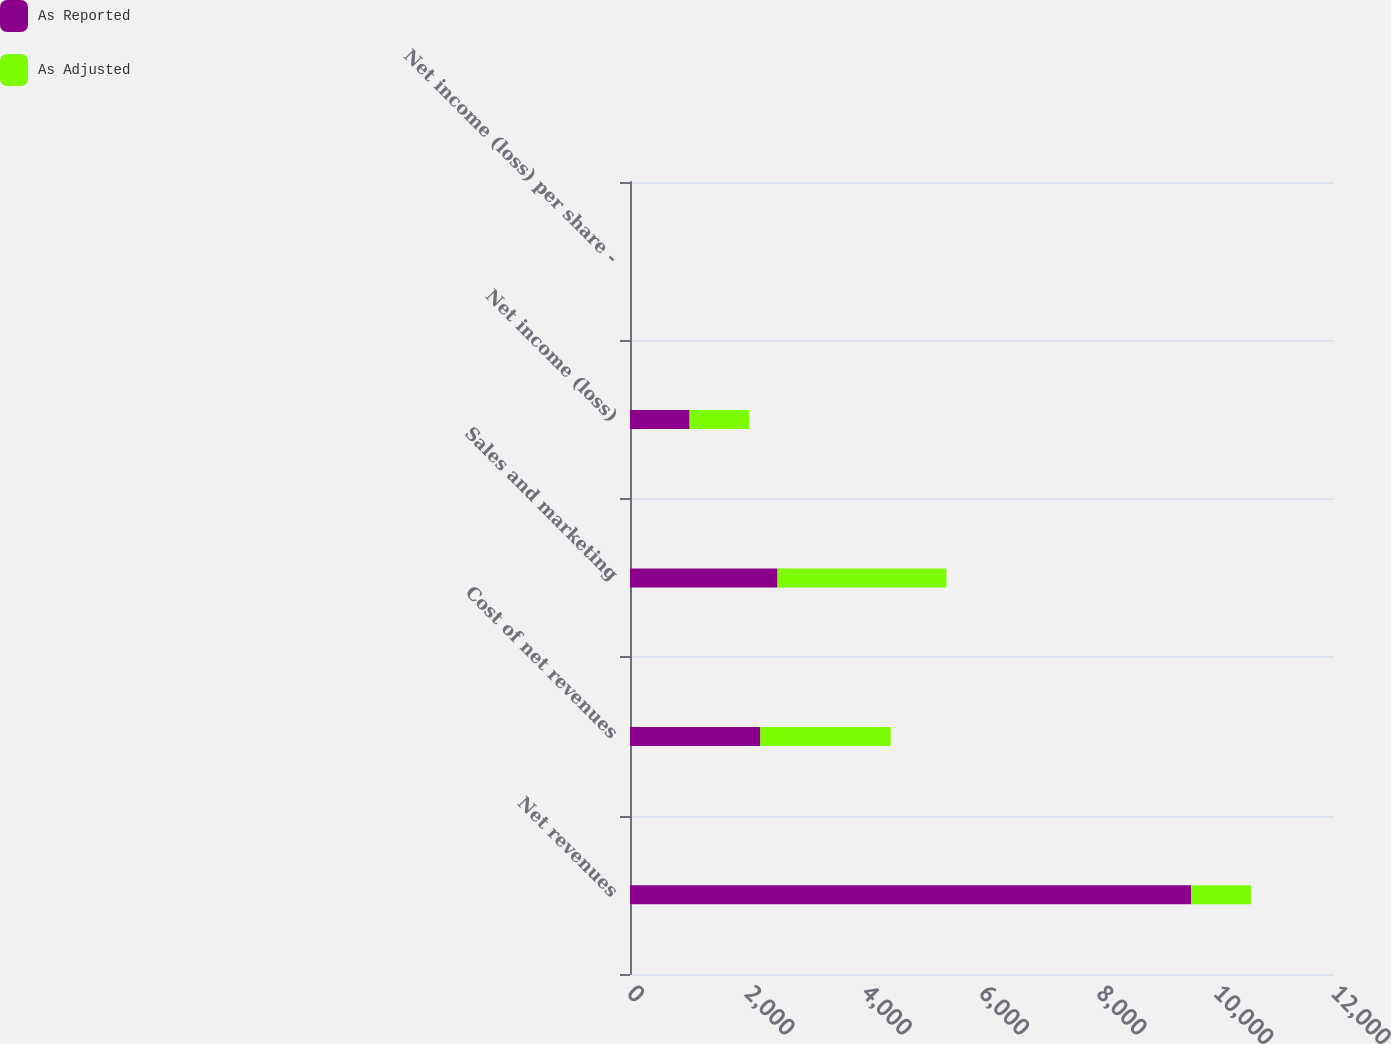Convert chart. <chart><loc_0><loc_0><loc_500><loc_500><stacked_bar_chart><ecel><fcel>Net revenues<fcel>Cost of net revenues<fcel>Sales and marketing<fcel>Net income (loss)<fcel>Net income (loss) per share -<nl><fcel>As Reported<fcel>9567<fcel>2222<fcel>2515<fcel>1016<fcel>0.95<nl><fcel>As Adjusted<fcel>1017<fcel>2221<fcel>2878<fcel>1017<fcel>0.95<nl></chart> 